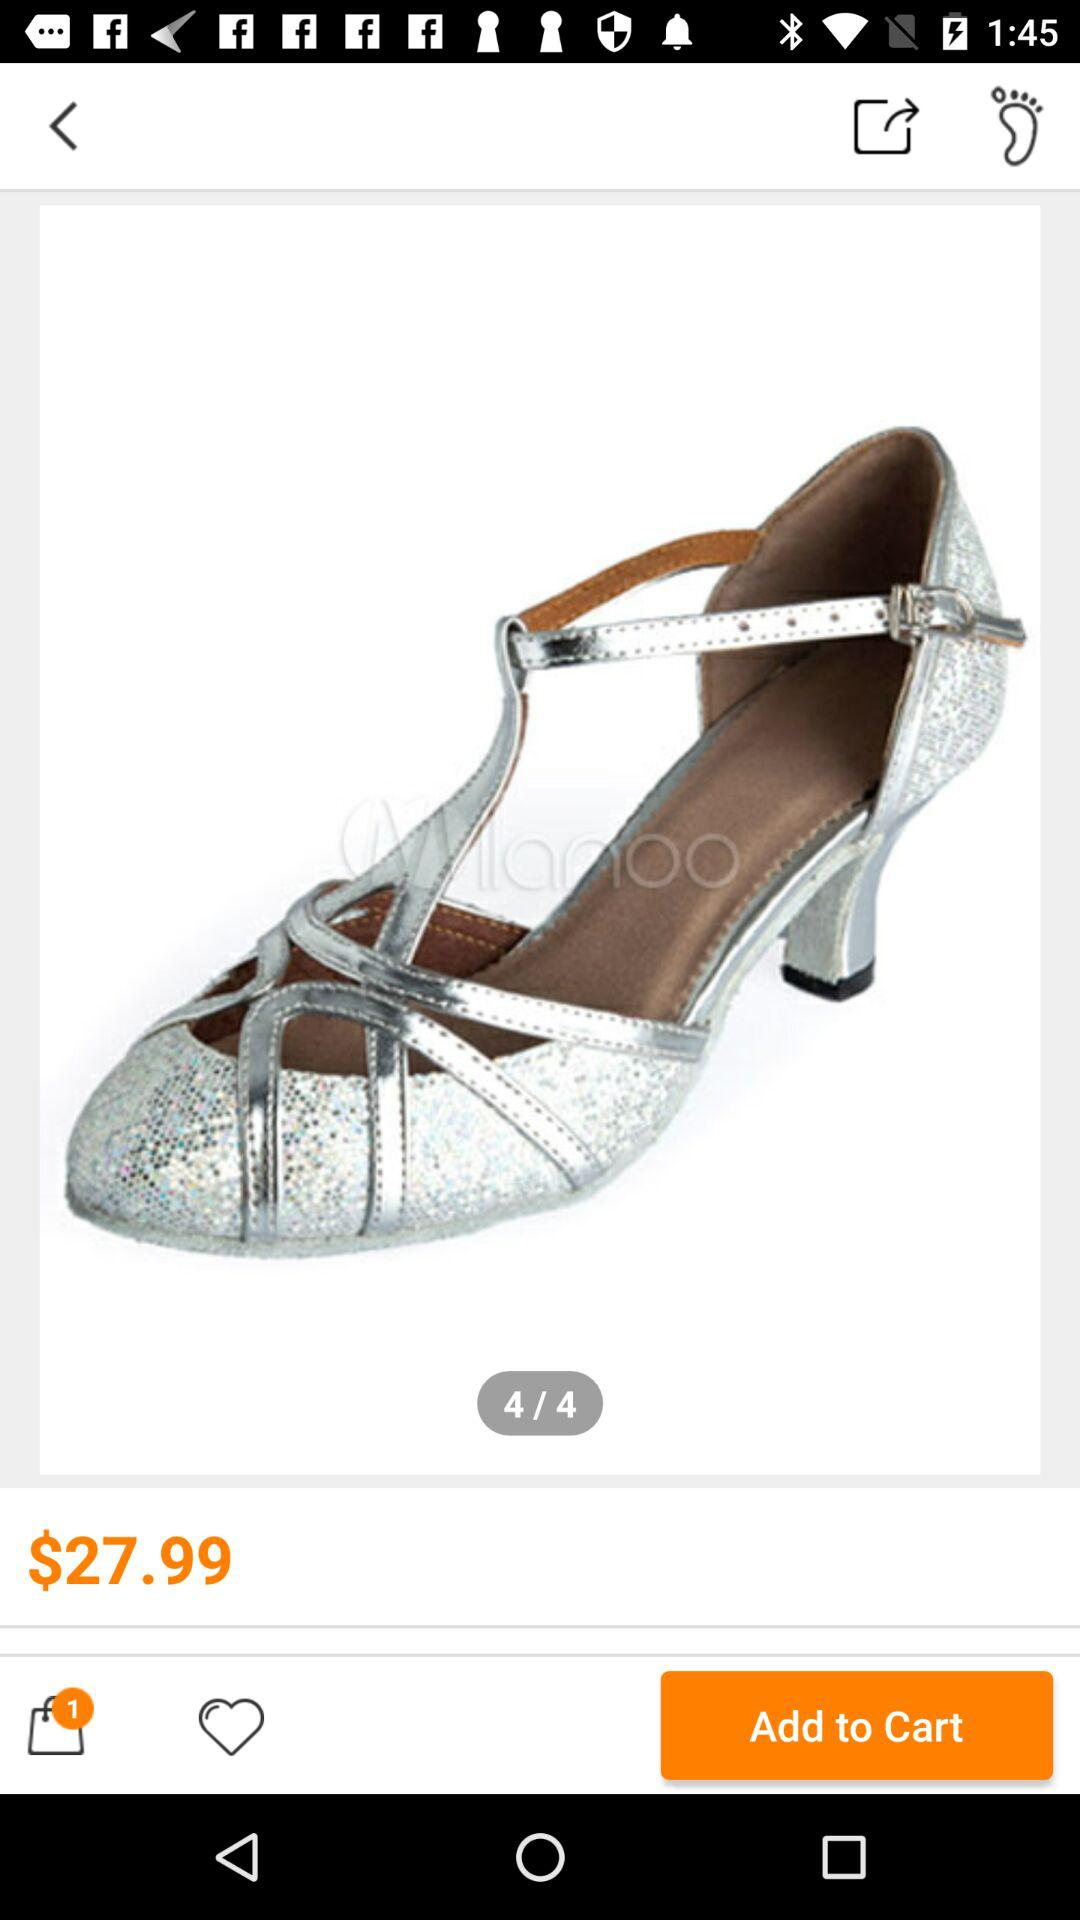What is the given price? The given price is 27.99 dollars. 